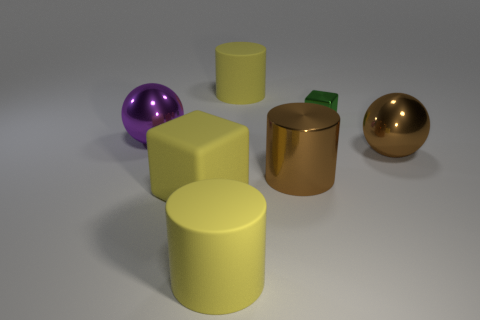Add 3 brown metal objects. How many objects exist? 10 Subtract all balls. How many objects are left? 5 Subtract all cyan metallic objects. Subtract all tiny metal objects. How many objects are left? 6 Add 4 spheres. How many spheres are left? 6 Add 4 green metal cubes. How many green metal cubes exist? 5 Subtract 0 cyan cubes. How many objects are left? 7 